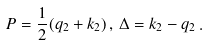<formula> <loc_0><loc_0><loc_500><loc_500>P = \frac { 1 } { 2 } ( q _ { 2 } + k _ { 2 } ) \, , \, \Delta = k _ { 2 } - q _ { 2 } \, .</formula> 